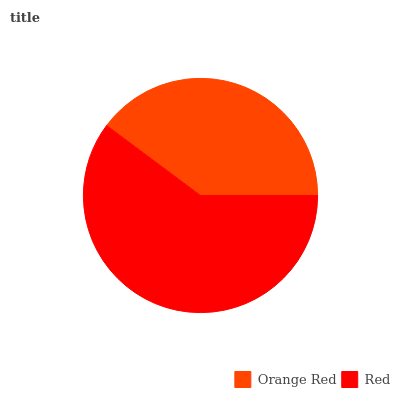Is Orange Red the minimum?
Answer yes or no. Yes. Is Red the maximum?
Answer yes or no. Yes. Is Red the minimum?
Answer yes or no. No. Is Red greater than Orange Red?
Answer yes or no. Yes. Is Orange Red less than Red?
Answer yes or no. Yes. Is Orange Red greater than Red?
Answer yes or no. No. Is Red less than Orange Red?
Answer yes or no. No. Is Red the high median?
Answer yes or no. Yes. Is Orange Red the low median?
Answer yes or no. Yes. Is Orange Red the high median?
Answer yes or no. No. Is Red the low median?
Answer yes or no. No. 